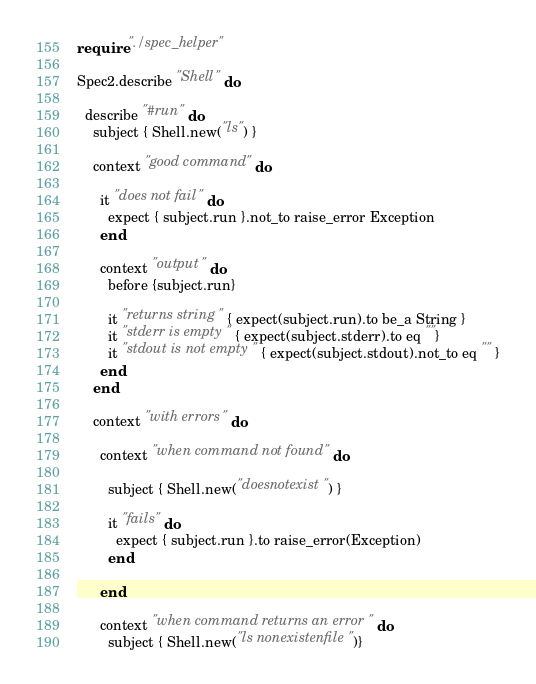<code> <loc_0><loc_0><loc_500><loc_500><_Crystal_>require "./spec_helper"

Spec2.describe "Shell" do

  describe "#run" do
    subject { Shell.new("ls") }

    context "good command" do

      it "does not fail" do
        expect { subject.run }.not_to raise_error Exception
      end

      context "output" do
        before {subject.run}

        it "returns string" { expect(subject.run).to be_a String }
        it "stderr is empty" { expect(subject.stderr).to eq ""}
        it "stdout is not empty" { expect(subject.stdout).not_to eq "" }
      end
    end

    context "with errors" do

      context "when command not found" do

        subject { Shell.new("doesnotexist") }

        it "fails" do
          expect { subject.run }.to raise_error(Exception)
        end

      end

      context "when command returns an error" do
        subject { Shell.new("ls nonexistenfile")}</code> 